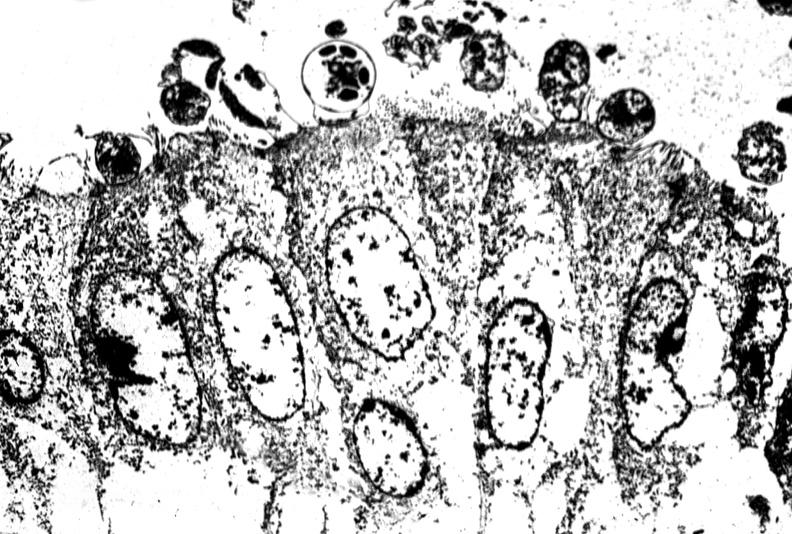does polycystic disease show colon biopsy, cryptosporidia?
Answer the question using a single word or phrase. No 